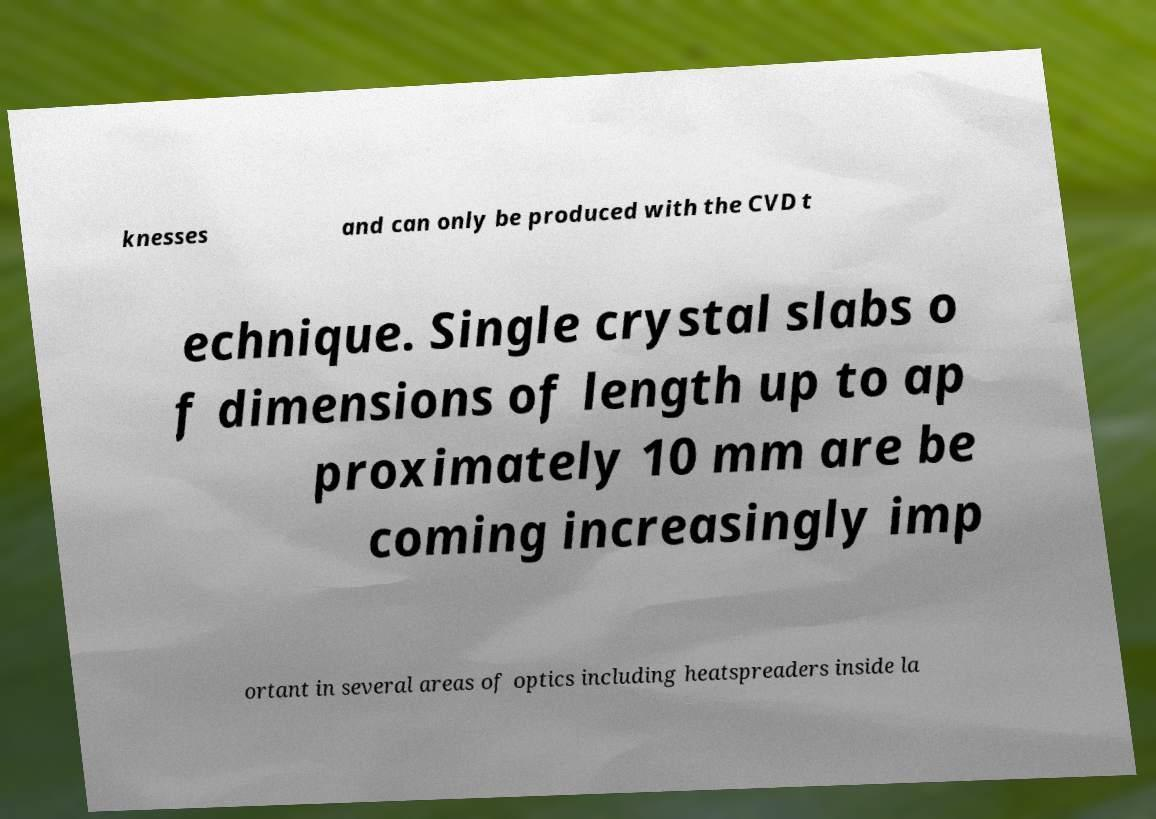Please read and relay the text visible in this image. What does it say? knesses and can only be produced with the CVD t echnique. Single crystal slabs o f dimensions of length up to ap proximately 10 mm are be coming increasingly imp ortant in several areas of optics including heatspreaders inside la 